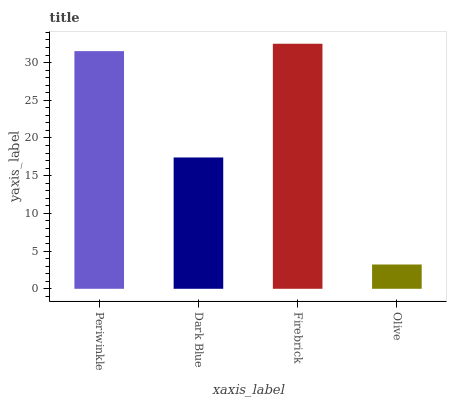Is Olive the minimum?
Answer yes or no. Yes. Is Firebrick the maximum?
Answer yes or no. Yes. Is Dark Blue the minimum?
Answer yes or no. No. Is Dark Blue the maximum?
Answer yes or no. No. Is Periwinkle greater than Dark Blue?
Answer yes or no. Yes. Is Dark Blue less than Periwinkle?
Answer yes or no. Yes. Is Dark Blue greater than Periwinkle?
Answer yes or no. No. Is Periwinkle less than Dark Blue?
Answer yes or no. No. Is Periwinkle the high median?
Answer yes or no. Yes. Is Dark Blue the low median?
Answer yes or no. Yes. Is Dark Blue the high median?
Answer yes or no. No. Is Olive the low median?
Answer yes or no. No. 